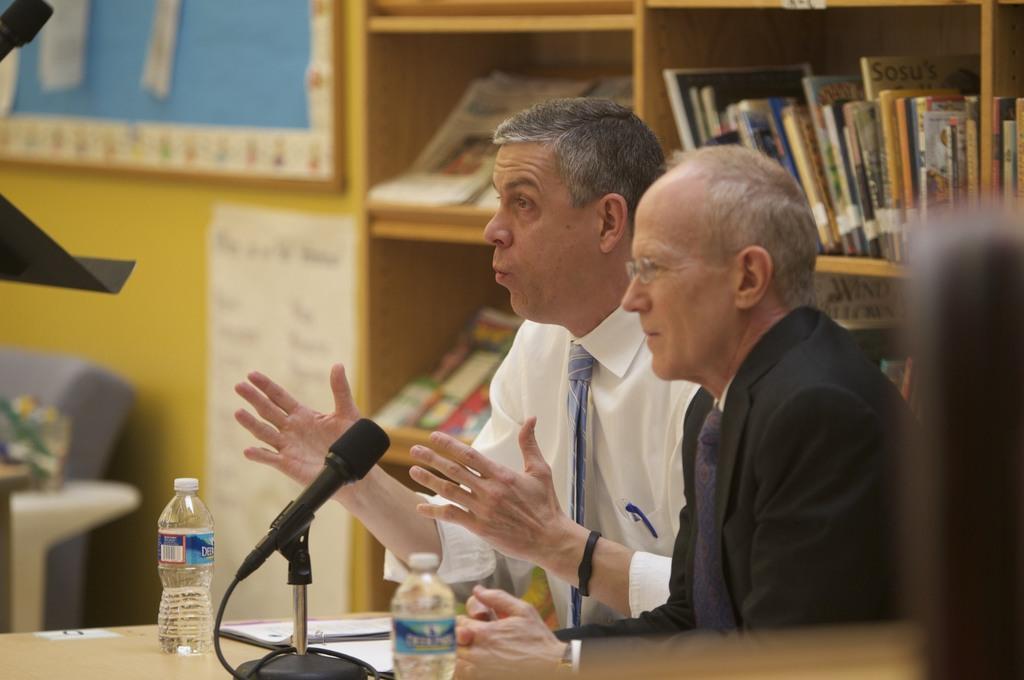Can you describe this image briefly? In this image I can see two people with different color dresses. I can see the table in-front of these people. On the table I can see the mic, papers and bottles. In the background I can see the books inside the cupboard. To the side I can see the board and paper to the wall. 